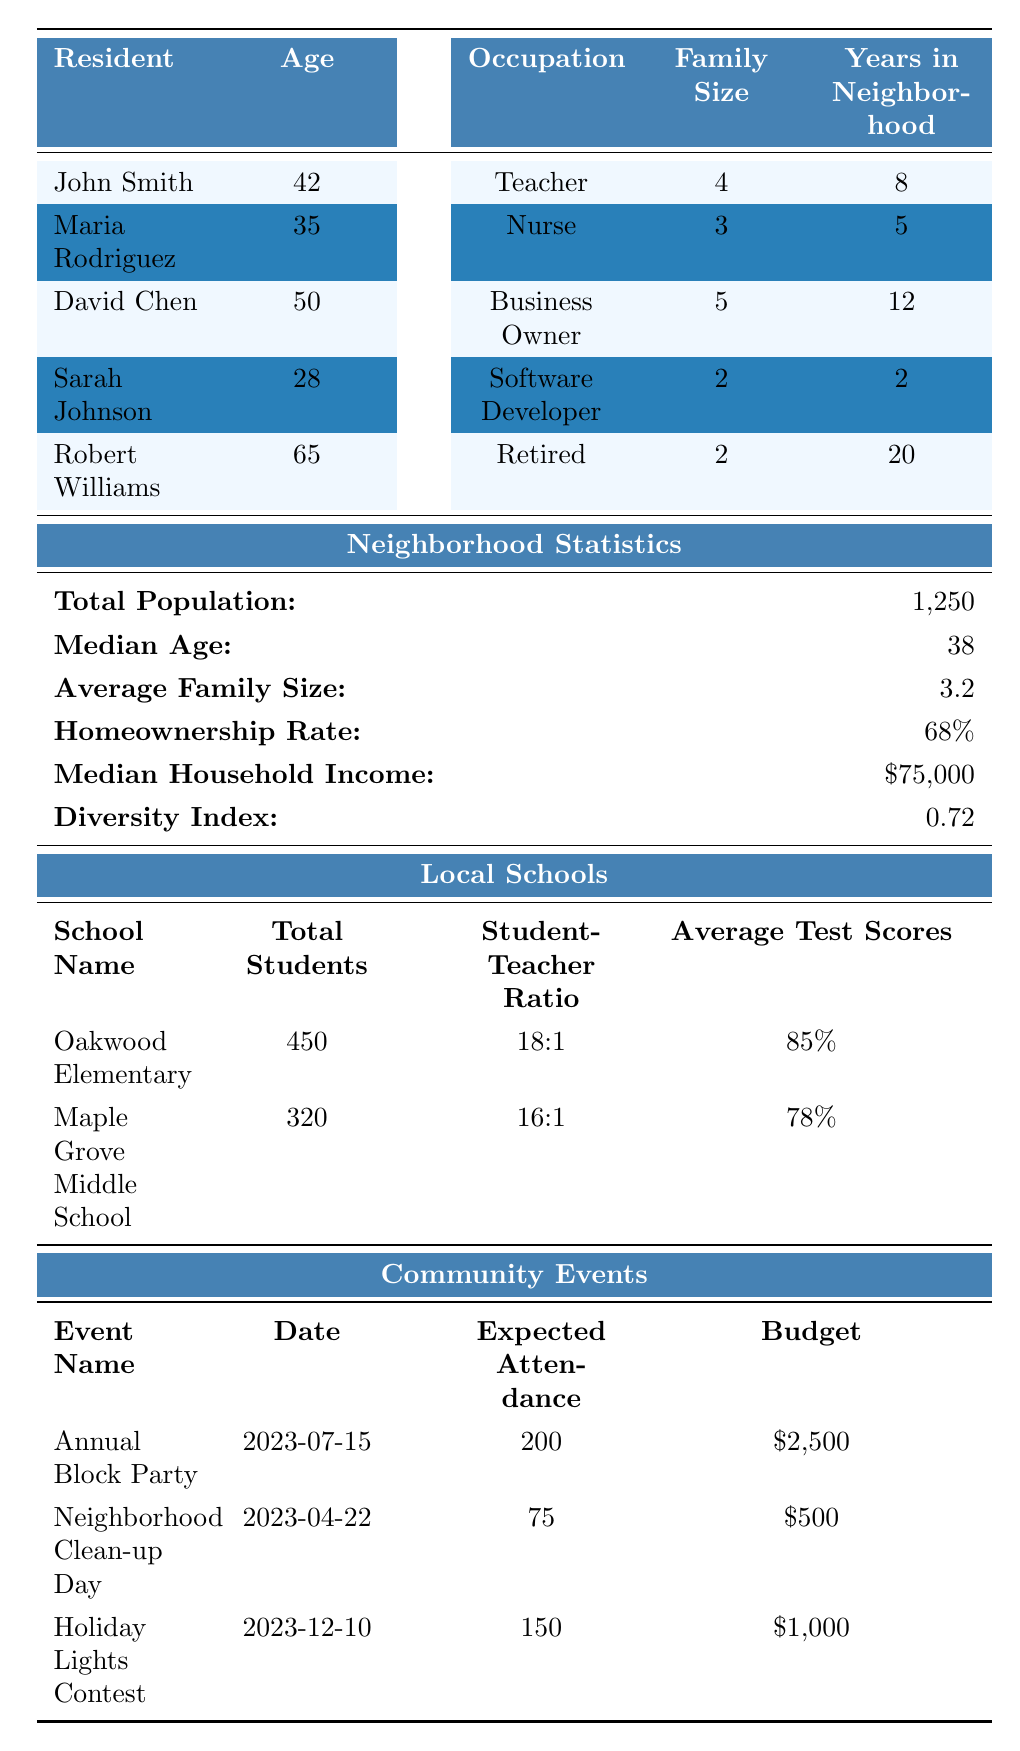What is the median age of the neighborhood residents? The median age is provided in the neighborhood statistics section of the table. It states that the median age is 38.
Answer: 38 How many residents own their homes? From the resident data, I see that John Smith, David Chen, and Robert Williams have "Owned" listed under home ownership. The count of these residents is 3.
Answer: 3 What percentage of the families in the neighborhood have children in local schools? There are 5 households in total. The households that have children in local schools are John Smith (2 children), Maria Rodriguez (1 child), and David Chen (3 children), which totals to 6 children. Thus, 3 out of 5 families have children in local schools. This is 60%.
Answer: 60% What is the total expected attendance for all community events listed? I will add up the expected attendance values from each event: 200 (Annual Block Party) + 75 (Neighborhood Clean-up Day) + 150 (Holiday Lights Contest) = 425.
Answer: 425 Which resident has lived in the neighborhood the longest? When I compare the "Years in Neighborhood" for each resident, Robert Williams has lived there for 20 years, which is the highest.
Answer: Robert Williams Is the average family size larger than the median family size? The average family size is stated as 3.2 and the median family size can be inferred from the family sizes of the residents (4, 3, 5, 2, 2), which is calculated to be 3. The average size is greater than the median size.
Answer: Yes What is the homeownership rate in the neighborhood? The homeownership rate is directly provided in the neighborhood stats section of the table as 68%.
Answer: 68% How many children are in local schools compared to the total population? There are a total of 6 children in local schools (from John Smith, Maria Rodriguez, and David Chen). The total population is 1,250. To find the percentage, I calculate (6/1250) * 100 = 0.48%.
Answer: 0.48% What is the average test score for Oakwood Elementary? The average test score for Oakwood Elementary is explicitly stated in the local schools section of the table as 85%.
Answer: 85% Which community event has the highest budget? Looking at the budget values for each event, the Annual Block Party has a budget of $2,500, which is the highest among the listed events.
Answer: Annual Block Party 